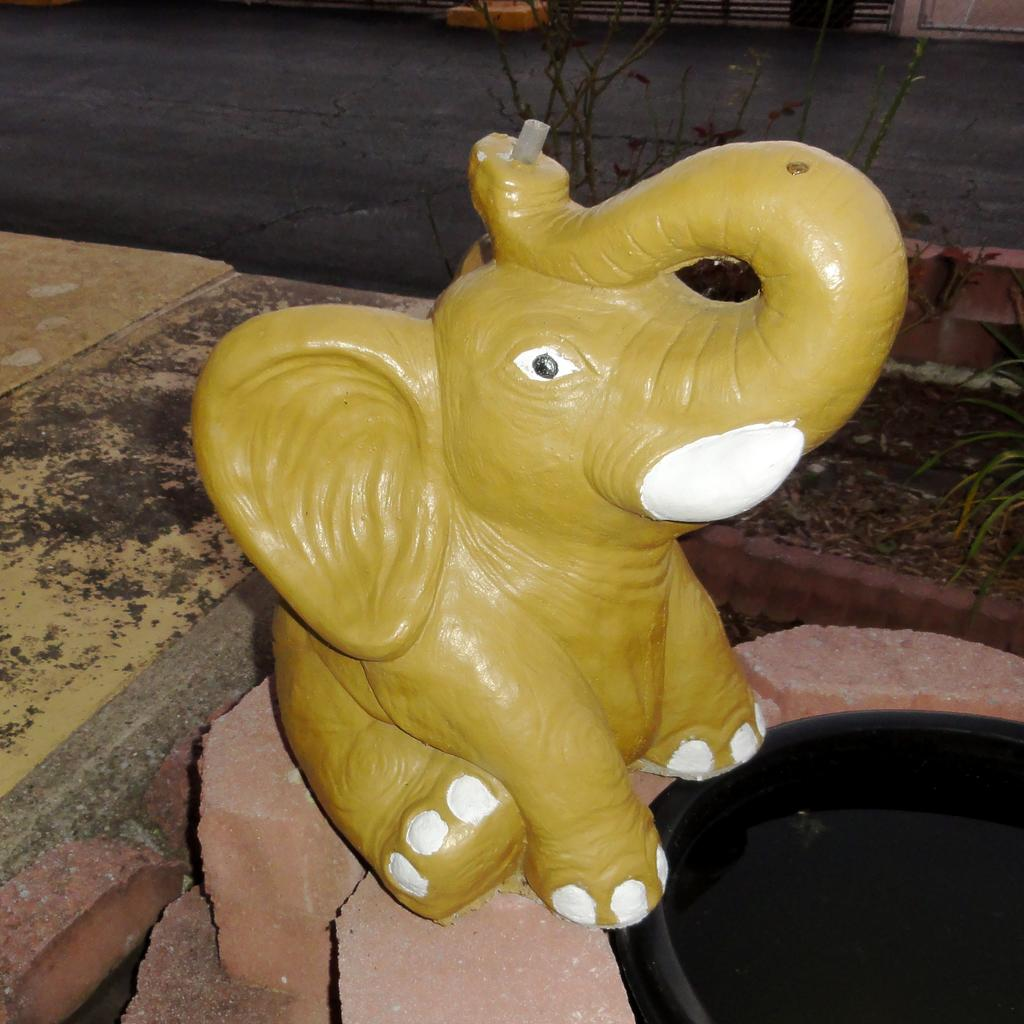What is the main subject of the image? There is a statue of an elephant in the image. What colors are used for the statue? The statue is yellow and white in color. What can be seen in the background of the image? There is a road and plants visible in the background of the image. Are there any other objects visible in the background? Yes, there are other objects visible in the background of the image. How many toes can be seen on the elephant's feet in the image? There is no elephant present in the image; it is a statue of an elephant. Therefore, it is not possible to count the toes on its feet. 